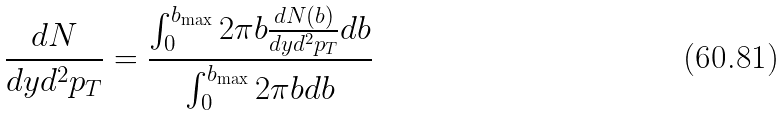Convert formula to latex. <formula><loc_0><loc_0><loc_500><loc_500>\frac { d N } { d y d ^ { 2 } p _ { T } } = \frac { \int _ { 0 } ^ { b _ { \max } } 2 \pi b \frac { d N ( b ) } { d y d ^ { 2 } p _ { T } } d b } { \int _ { 0 } ^ { b _ { \max } } 2 \pi b d b }</formula> 